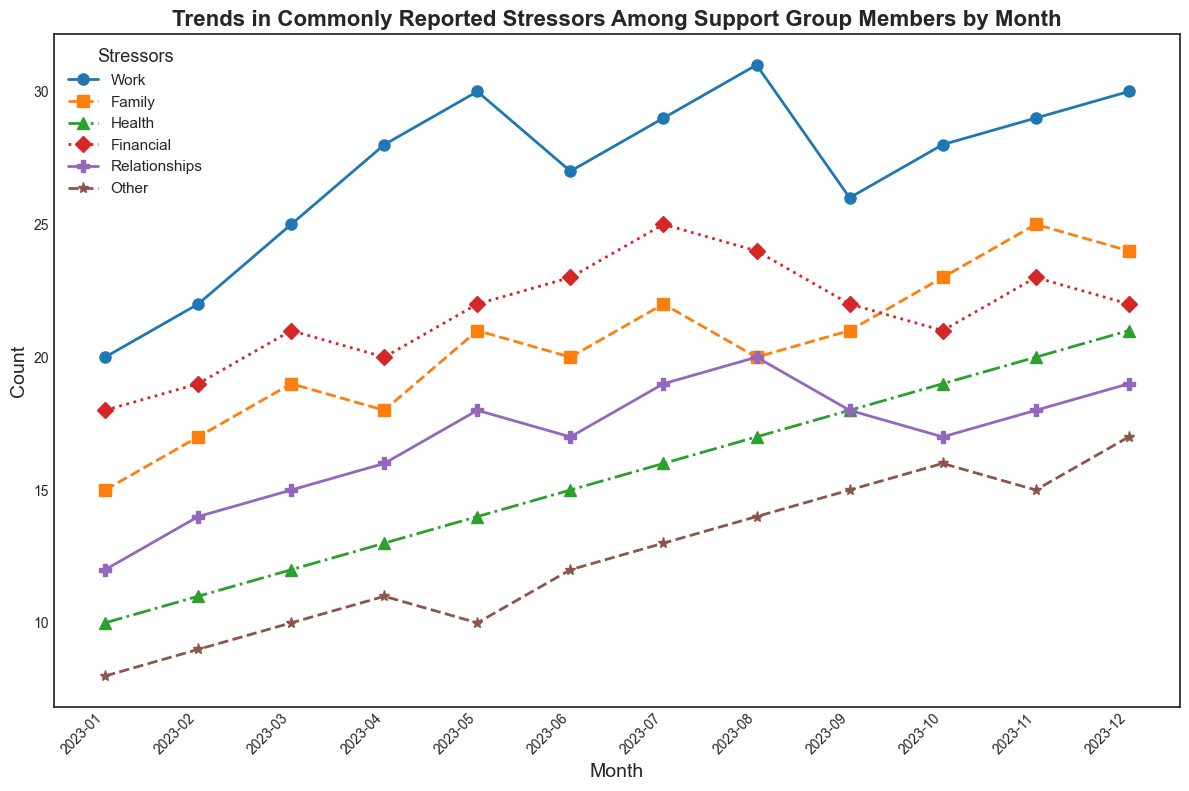What's the highest reported stressor in October 2023? To find the highest reported stressor in October 2023, locate October on the x-axis and compare the heights of the different lines. The highest point on the vertical scale for October corresponds to Relationships which reached 23.
Answer: Relationships Which stressor showed a consistent increase each month from January to December 2023? Observing the different lines in the chart, we see that the line representing "Health" increases consistently every month from January to December. The values steadily rise from 10 to 21.
Answer: Health How many stressors decreased from August to September 2023? Locate August and September on the x-axis and observe the vertical positions of the lines. Work decreased from 31 to 26, and Relationships decreased from 20 to 18. Thus, two stressors decreased.
Answer: Two What is the sum of all stressors reported in May 2023? The values for May are: Work (30), Family (21), Health (14), Financial (22), Relationships (18), and Other (10). Adding these, 30+21+14+22+18+10 = 115.
Answer: 115 Between Family and Financial stressors, which had a higher count in July 2023? Locate July on the x-axis and compare the positions of Family and Financial lines. Family is at 22, while Financial is at 25. Thus, Financial is higher.
Answer: Financial What is the average number of Health-related stressors reported from January to December 2023? The Health values are 10, 11, 12, 13, 14, 15, 16, 17, 18, 19, 20, and 21. Sum these (186) and divide by 12 months. 186 / 12 = 15.5.
Answer: 15.5 Which month saw the highest overall count of stressors reported? To determine the highest overall count, sum the values for each month. The sum for December is highest with 30+24+21+22+19+17 = 133.
Answer: December In November, how many more reports were there for Work than Other stressors? Observe the lines for November: Work is at 29, and Other is at 15. The difference is 29 - 15 = 14.
Answer: 14 